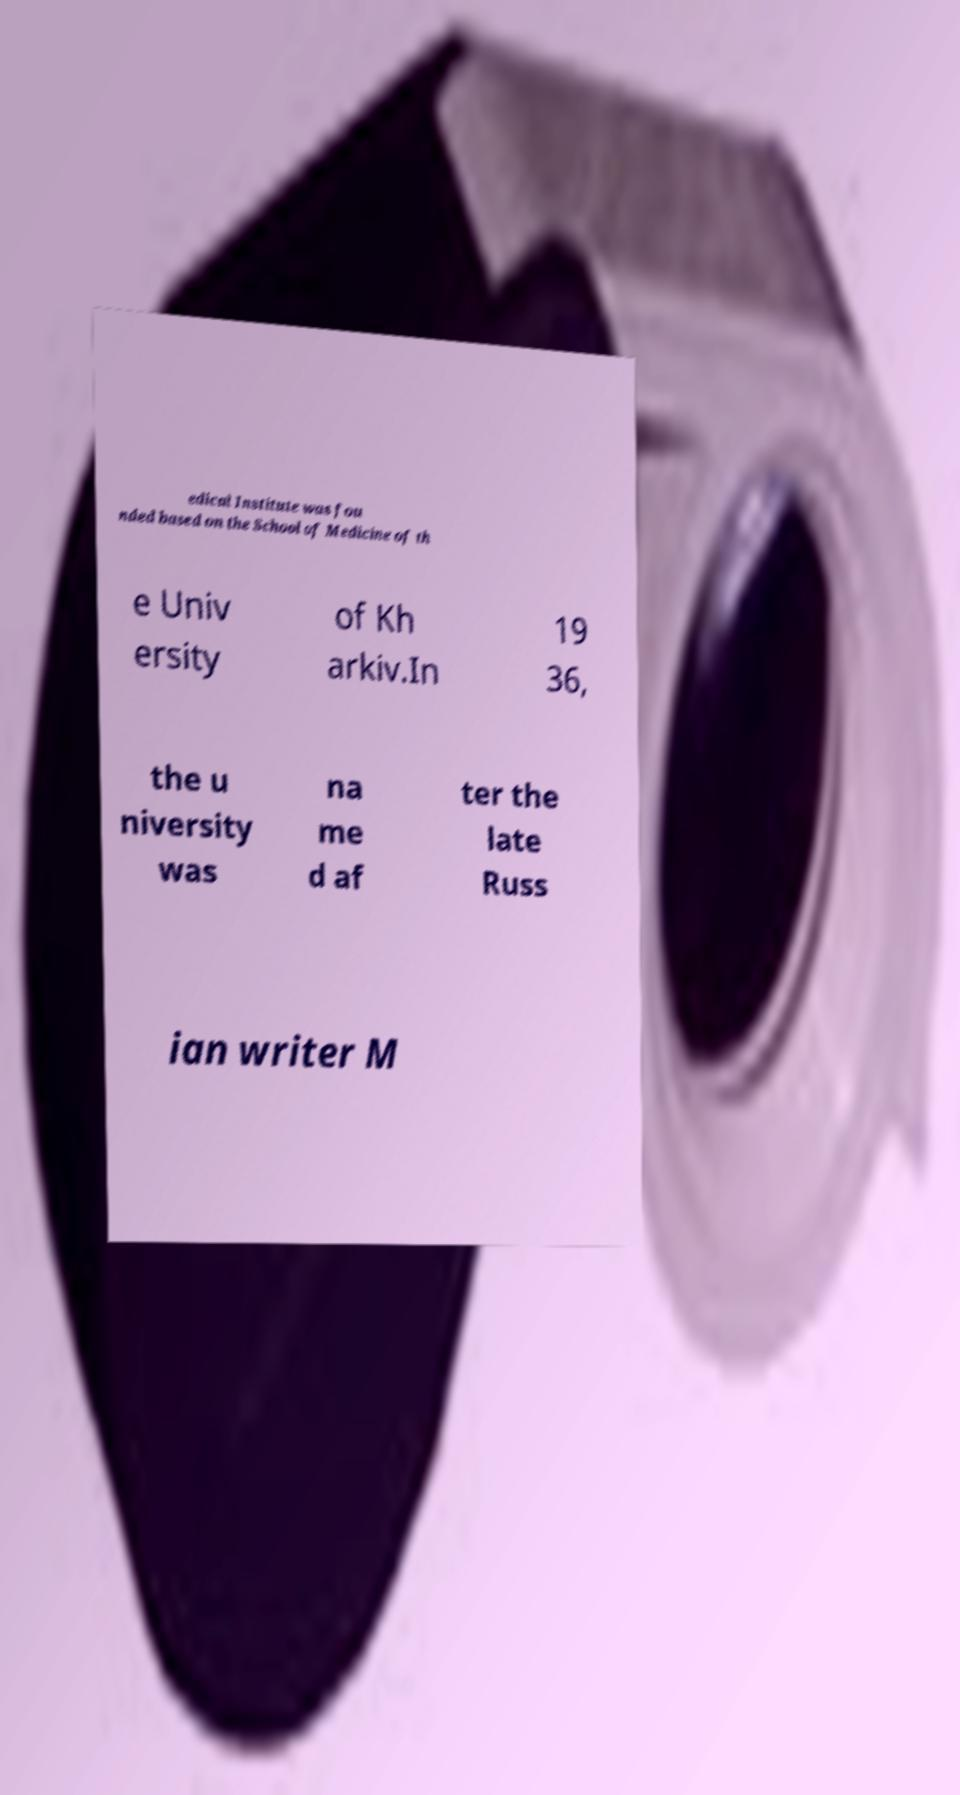I need the written content from this picture converted into text. Can you do that? edical Institute was fou nded based on the School of Medicine of th e Univ ersity of Kh arkiv.In 19 36, the u niversity was na me d af ter the late Russ ian writer M 